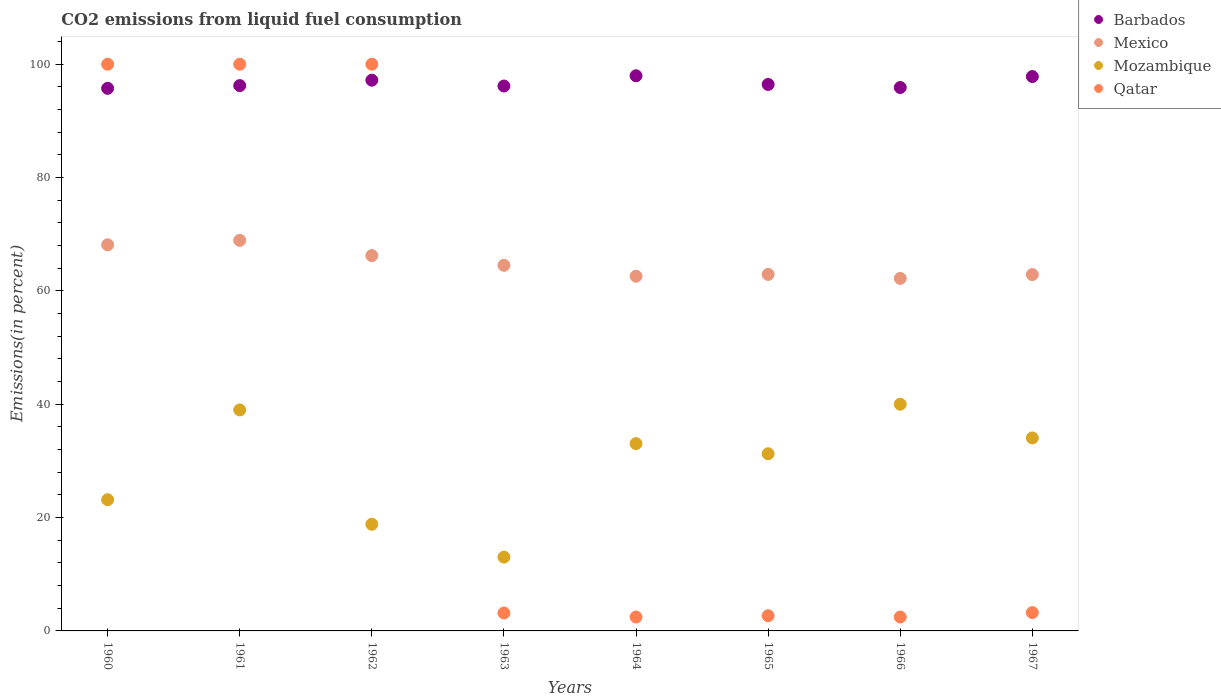Is the number of dotlines equal to the number of legend labels?
Give a very brief answer. Yes. What is the total CO2 emitted in Mexico in 1963?
Keep it short and to the point. 64.51. Across all years, what is the maximum total CO2 emitted in Mozambique?
Offer a terse response. 40. Across all years, what is the minimum total CO2 emitted in Mexico?
Make the answer very short. 62.21. What is the total total CO2 emitted in Qatar in the graph?
Keep it short and to the point. 313.99. What is the difference between the total CO2 emitted in Mozambique in 1965 and that in 1966?
Provide a succinct answer. -8.74. What is the difference between the total CO2 emitted in Mexico in 1961 and the total CO2 emitted in Barbados in 1963?
Provide a short and direct response. -27.23. What is the average total CO2 emitted in Mexico per year?
Give a very brief answer. 64.8. In the year 1962, what is the difference between the total CO2 emitted in Mexico and total CO2 emitted in Barbados?
Give a very brief answer. -30.95. In how many years, is the total CO2 emitted in Mexico greater than 84 %?
Offer a terse response. 0. What is the ratio of the total CO2 emitted in Mexico in 1961 to that in 1964?
Give a very brief answer. 1.1. Is the total CO2 emitted in Mexico in 1964 less than that in 1966?
Offer a terse response. No. What is the difference between the highest and the lowest total CO2 emitted in Mozambique?
Offer a terse response. 26.98. In how many years, is the total CO2 emitted in Mozambique greater than the average total CO2 emitted in Mozambique taken over all years?
Your answer should be compact. 5. Is the sum of the total CO2 emitted in Qatar in 1964 and 1967 greater than the maximum total CO2 emitted in Mozambique across all years?
Your response must be concise. No. Is it the case that in every year, the sum of the total CO2 emitted in Mexico and total CO2 emitted in Qatar  is greater than the sum of total CO2 emitted in Mozambique and total CO2 emitted in Barbados?
Keep it short and to the point. No. Does the total CO2 emitted in Qatar monotonically increase over the years?
Make the answer very short. No. Is the total CO2 emitted in Qatar strictly greater than the total CO2 emitted in Mexico over the years?
Offer a terse response. No. Is the total CO2 emitted in Mexico strictly less than the total CO2 emitted in Mozambique over the years?
Offer a very short reply. No. How many years are there in the graph?
Make the answer very short. 8. What is the difference between two consecutive major ticks on the Y-axis?
Give a very brief answer. 20. Does the graph contain any zero values?
Offer a terse response. No. Where does the legend appear in the graph?
Offer a terse response. Top right. What is the title of the graph?
Ensure brevity in your answer.  CO2 emissions from liquid fuel consumption. Does "Middle income" appear as one of the legend labels in the graph?
Provide a short and direct response. No. What is the label or title of the X-axis?
Make the answer very short. Years. What is the label or title of the Y-axis?
Ensure brevity in your answer.  Emissions(in percent). What is the Emissions(in percent) in Barbados in 1960?
Give a very brief answer. 95.74. What is the Emissions(in percent) in Mexico in 1960?
Provide a short and direct response. 68.13. What is the Emissions(in percent) in Mozambique in 1960?
Keep it short and to the point. 23.15. What is the Emissions(in percent) in Qatar in 1960?
Offer a very short reply. 100. What is the Emissions(in percent) in Barbados in 1961?
Offer a terse response. 96.23. What is the Emissions(in percent) of Mexico in 1961?
Provide a short and direct response. 68.92. What is the Emissions(in percent) of Mozambique in 1961?
Offer a terse response. 39. What is the Emissions(in percent) of Qatar in 1961?
Your answer should be compact. 100. What is the Emissions(in percent) of Barbados in 1962?
Your response must be concise. 97.18. What is the Emissions(in percent) in Mexico in 1962?
Your answer should be very brief. 66.23. What is the Emissions(in percent) in Mozambique in 1962?
Offer a very short reply. 18.82. What is the Emissions(in percent) in Qatar in 1962?
Give a very brief answer. 100. What is the Emissions(in percent) in Barbados in 1963?
Give a very brief answer. 96.15. What is the Emissions(in percent) in Mexico in 1963?
Provide a short and direct response. 64.51. What is the Emissions(in percent) of Mozambique in 1963?
Ensure brevity in your answer.  13.02. What is the Emissions(in percent) in Qatar in 1963?
Your answer should be very brief. 3.17. What is the Emissions(in percent) of Barbados in 1964?
Your response must be concise. 97.96. What is the Emissions(in percent) in Mexico in 1964?
Your answer should be compact. 62.59. What is the Emissions(in percent) of Mozambique in 1964?
Offer a terse response. 33.05. What is the Emissions(in percent) in Qatar in 1964?
Ensure brevity in your answer.  2.45. What is the Emissions(in percent) in Barbados in 1965?
Offer a very short reply. 96.43. What is the Emissions(in percent) in Mexico in 1965?
Your response must be concise. 62.91. What is the Emissions(in percent) of Mozambique in 1965?
Make the answer very short. 31.26. What is the Emissions(in percent) of Qatar in 1965?
Your answer should be very brief. 2.68. What is the Emissions(in percent) of Barbados in 1966?
Keep it short and to the point. 95.89. What is the Emissions(in percent) of Mexico in 1966?
Make the answer very short. 62.21. What is the Emissions(in percent) in Qatar in 1966?
Provide a short and direct response. 2.45. What is the Emissions(in percent) of Barbados in 1967?
Offer a very short reply. 97.83. What is the Emissions(in percent) of Mexico in 1967?
Your answer should be compact. 62.88. What is the Emissions(in percent) in Mozambique in 1967?
Give a very brief answer. 34.05. What is the Emissions(in percent) of Qatar in 1967?
Keep it short and to the point. 3.23. Across all years, what is the maximum Emissions(in percent) in Barbados?
Keep it short and to the point. 97.96. Across all years, what is the maximum Emissions(in percent) in Mexico?
Offer a terse response. 68.92. Across all years, what is the maximum Emissions(in percent) in Mozambique?
Provide a succinct answer. 40. Across all years, what is the minimum Emissions(in percent) of Barbados?
Provide a short and direct response. 95.74. Across all years, what is the minimum Emissions(in percent) of Mexico?
Give a very brief answer. 62.21. Across all years, what is the minimum Emissions(in percent) of Mozambique?
Provide a succinct answer. 13.02. Across all years, what is the minimum Emissions(in percent) in Qatar?
Your response must be concise. 2.45. What is the total Emissions(in percent) in Barbados in the graph?
Your answer should be compact. 773.41. What is the total Emissions(in percent) of Mexico in the graph?
Make the answer very short. 518.38. What is the total Emissions(in percent) in Mozambique in the graph?
Your answer should be compact. 232.35. What is the total Emissions(in percent) of Qatar in the graph?
Ensure brevity in your answer.  313.99. What is the difference between the Emissions(in percent) of Barbados in 1960 and that in 1961?
Offer a very short reply. -0.48. What is the difference between the Emissions(in percent) in Mexico in 1960 and that in 1961?
Your response must be concise. -0.79. What is the difference between the Emissions(in percent) in Mozambique in 1960 and that in 1961?
Ensure brevity in your answer.  -15.85. What is the difference between the Emissions(in percent) in Barbados in 1960 and that in 1962?
Keep it short and to the point. -1.44. What is the difference between the Emissions(in percent) in Mexico in 1960 and that in 1962?
Provide a short and direct response. 1.9. What is the difference between the Emissions(in percent) in Mozambique in 1960 and that in 1962?
Provide a short and direct response. 4.33. What is the difference between the Emissions(in percent) of Barbados in 1960 and that in 1963?
Keep it short and to the point. -0.41. What is the difference between the Emissions(in percent) in Mexico in 1960 and that in 1963?
Keep it short and to the point. 3.62. What is the difference between the Emissions(in percent) of Mozambique in 1960 and that in 1963?
Your response must be concise. 10.13. What is the difference between the Emissions(in percent) of Qatar in 1960 and that in 1963?
Ensure brevity in your answer.  96.83. What is the difference between the Emissions(in percent) in Barbados in 1960 and that in 1964?
Make the answer very short. -2.21. What is the difference between the Emissions(in percent) in Mexico in 1960 and that in 1964?
Your answer should be very brief. 5.54. What is the difference between the Emissions(in percent) in Mozambique in 1960 and that in 1964?
Provide a succinct answer. -9.9. What is the difference between the Emissions(in percent) in Qatar in 1960 and that in 1964?
Offer a very short reply. 97.55. What is the difference between the Emissions(in percent) in Barbados in 1960 and that in 1965?
Provide a short and direct response. -0.68. What is the difference between the Emissions(in percent) in Mexico in 1960 and that in 1965?
Your response must be concise. 5.22. What is the difference between the Emissions(in percent) in Mozambique in 1960 and that in 1965?
Keep it short and to the point. -8.11. What is the difference between the Emissions(in percent) in Qatar in 1960 and that in 1965?
Provide a short and direct response. 97.32. What is the difference between the Emissions(in percent) of Barbados in 1960 and that in 1966?
Provide a short and direct response. -0.15. What is the difference between the Emissions(in percent) of Mexico in 1960 and that in 1966?
Keep it short and to the point. 5.93. What is the difference between the Emissions(in percent) of Mozambique in 1960 and that in 1966?
Offer a very short reply. -16.85. What is the difference between the Emissions(in percent) of Qatar in 1960 and that in 1966?
Make the answer very short. 97.55. What is the difference between the Emissions(in percent) in Barbados in 1960 and that in 1967?
Your response must be concise. -2.08. What is the difference between the Emissions(in percent) of Mexico in 1960 and that in 1967?
Provide a short and direct response. 5.25. What is the difference between the Emissions(in percent) of Mozambique in 1960 and that in 1967?
Make the answer very short. -10.9. What is the difference between the Emissions(in percent) in Qatar in 1960 and that in 1967?
Your answer should be very brief. 96.77. What is the difference between the Emissions(in percent) in Barbados in 1961 and that in 1962?
Your answer should be very brief. -0.96. What is the difference between the Emissions(in percent) in Mexico in 1961 and that in 1962?
Make the answer very short. 2.69. What is the difference between the Emissions(in percent) in Mozambique in 1961 and that in 1962?
Your answer should be compact. 20.18. What is the difference between the Emissions(in percent) of Qatar in 1961 and that in 1962?
Provide a succinct answer. 0. What is the difference between the Emissions(in percent) of Barbados in 1961 and that in 1963?
Offer a very short reply. 0.07. What is the difference between the Emissions(in percent) in Mexico in 1961 and that in 1963?
Keep it short and to the point. 4.41. What is the difference between the Emissions(in percent) in Mozambique in 1961 and that in 1963?
Your answer should be compact. 25.97. What is the difference between the Emissions(in percent) of Qatar in 1961 and that in 1963?
Provide a short and direct response. 96.83. What is the difference between the Emissions(in percent) of Barbados in 1961 and that in 1964?
Provide a short and direct response. -1.73. What is the difference between the Emissions(in percent) of Mexico in 1961 and that in 1964?
Keep it short and to the point. 6.33. What is the difference between the Emissions(in percent) of Mozambique in 1961 and that in 1964?
Offer a very short reply. 5.95. What is the difference between the Emissions(in percent) in Qatar in 1961 and that in 1964?
Offer a very short reply. 97.55. What is the difference between the Emissions(in percent) of Barbados in 1961 and that in 1965?
Your answer should be compact. -0.2. What is the difference between the Emissions(in percent) of Mexico in 1961 and that in 1965?
Make the answer very short. 6.01. What is the difference between the Emissions(in percent) in Mozambique in 1961 and that in 1965?
Your response must be concise. 7.74. What is the difference between the Emissions(in percent) of Qatar in 1961 and that in 1965?
Keep it short and to the point. 97.32. What is the difference between the Emissions(in percent) of Barbados in 1961 and that in 1966?
Your answer should be very brief. 0.34. What is the difference between the Emissions(in percent) in Mexico in 1961 and that in 1966?
Provide a succinct answer. 6.71. What is the difference between the Emissions(in percent) in Mozambique in 1961 and that in 1966?
Offer a very short reply. -1. What is the difference between the Emissions(in percent) in Qatar in 1961 and that in 1966?
Give a very brief answer. 97.55. What is the difference between the Emissions(in percent) in Barbados in 1961 and that in 1967?
Your response must be concise. -1.6. What is the difference between the Emissions(in percent) of Mexico in 1961 and that in 1967?
Offer a terse response. 6.04. What is the difference between the Emissions(in percent) of Mozambique in 1961 and that in 1967?
Provide a short and direct response. 4.95. What is the difference between the Emissions(in percent) of Qatar in 1961 and that in 1967?
Make the answer very short. 96.77. What is the difference between the Emissions(in percent) of Barbados in 1962 and that in 1963?
Keep it short and to the point. 1.03. What is the difference between the Emissions(in percent) of Mexico in 1962 and that in 1963?
Your response must be concise. 1.72. What is the difference between the Emissions(in percent) of Mozambique in 1962 and that in 1963?
Offer a terse response. 5.79. What is the difference between the Emissions(in percent) in Qatar in 1962 and that in 1963?
Provide a short and direct response. 96.83. What is the difference between the Emissions(in percent) of Barbados in 1962 and that in 1964?
Your answer should be very brief. -0.78. What is the difference between the Emissions(in percent) in Mexico in 1962 and that in 1964?
Keep it short and to the point. 3.64. What is the difference between the Emissions(in percent) of Mozambique in 1962 and that in 1964?
Offer a terse response. -14.23. What is the difference between the Emissions(in percent) in Qatar in 1962 and that in 1964?
Provide a succinct answer. 97.55. What is the difference between the Emissions(in percent) in Barbados in 1962 and that in 1965?
Offer a very short reply. 0.75. What is the difference between the Emissions(in percent) of Mexico in 1962 and that in 1965?
Provide a succinct answer. 3.32. What is the difference between the Emissions(in percent) in Mozambique in 1962 and that in 1965?
Your answer should be very brief. -12.44. What is the difference between the Emissions(in percent) in Qatar in 1962 and that in 1965?
Offer a terse response. 97.32. What is the difference between the Emissions(in percent) in Barbados in 1962 and that in 1966?
Give a very brief answer. 1.29. What is the difference between the Emissions(in percent) in Mexico in 1962 and that in 1966?
Provide a succinct answer. 4.03. What is the difference between the Emissions(in percent) in Mozambique in 1962 and that in 1966?
Offer a terse response. -21.18. What is the difference between the Emissions(in percent) in Qatar in 1962 and that in 1966?
Ensure brevity in your answer.  97.55. What is the difference between the Emissions(in percent) of Barbados in 1962 and that in 1967?
Provide a succinct answer. -0.64. What is the difference between the Emissions(in percent) in Mexico in 1962 and that in 1967?
Offer a terse response. 3.35. What is the difference between the Emissions(in percent) in Mozambique in 1962 and that in 1967?
Your answer should be compact. -15.23. What is the difference between the Emissions(in percent) of Qatar in 1962 and that in 1967?
Keep it short and to the point. 96.77. What is the difference between the Emissions(in percent) of Barbados in 1963 and that in 1964?
Your response must be concise. -1.81. What is the difference between the Emissions(in percent) of Mexico in 1963 and that in 1964?
Make the answer very short. 1.92. What is the difference between the Emissions(in percent) of Mozambique in 1963 and that in 1964?
Make the answer very short. -20.02. What is the difference between the Emissions(in percent) in Qatar in 1963 and that in 1964?
Ensure brevity in your answer.  0.71. What is the difference between the Emissions(in percent) in Barbados in 1963 and that in 1965?
Your answer should be very brief. -0.27. What is the difference between the Emissions(in percent) of Mexico in 1963 and that in 1965?
Keep it short and to the point. 1.6. What is the difference between the Emissions(in percent) of Mozambique in 1963 and that in 1965?
Make the answer very short. -18.24. What is the difference between the Emissions(in percent) of Qatar in 1963 and that in 1965?
Provide a short and direct response. 0.49. What is the difference between the Emissions(in percent) of Barbados in 1963 and that in 1966?
Provide a short and direct response. 0.26. What is the difference between the Emissions(in percent) of Mexico in 1963 and that in 1966?
Offer a very short reply. 2.31. What is the difference between the Emissions(in percent) of Mozambique in 1963 and that in 1966?
Your response must be concise. -26.98. What is the difference between the Emissions(in percent) of Qatar in 1963 and that in 1966?
Keep it short and to the point. 0.71. What is the difference between the Emissions(in percent) of Barbados in 1963 and that in 1967?
Ensure brevity in your answer.  -1.67. What is the difference between the Emissions(in percent) in Mexico in 1963 and that in 1967?
Offer a very short reply. 1.63. What is the difference between the Emissions(in percent) of Mozambique in 1963 and that in 1967?
Provide a succinct answer. -21.03. What is the difference between the Emissions(in percent) of Qatar in 1963 and that in 1967?
Offer a terse response. -0.07. What is the difference between the Emissions(in percent) in Barbados in 1964 and that in 1965?
Give a very brief answer. 1.53. What is the difference between the Emissions(in percent) of Mexico in 1964 and that in 1965?
Your answer should be very brief. -0.32. What is the difference between the Emissions(in percent) in Mozambique in 1964 and that in 1965?
Offer a very short reply. 1.79. What is the difference between the Emissions(in percent) of Qatar in 1964 and that in 1965?
Your response must be concise. -0.23. What is the difference between the Emissions(in percent) of Barbados in 1964 and that in 1966?
Your response must be concise. 2.07. What is the difference between the Emissions(in percent) of Mexico in 1964 and that in 1966?
Give a very brief answer. 0.38. What is the difference between the Emissions(in percent) of Mozambique in 1964 and that in 1966?
Offer a terse response. -6.95. What is the difference between the Emissions(in percent) in Qatar in 1964 and that in 1966?
Provide a short and direct response. 0. What is the difference between the Emissions(in percent) in Barbados in 1964 and that in 1967?
Your answer should be compact. 0.13. What is the difference between the Emissions(in percent) in Mexico in 1964 and that in 1967?
Offer a terse response. -0.29. What is the difference between the Emissions(in percent) in Mozambique in 1964 and that in 1967?
Provide a short and direct response. -1. What is the difference between the Emissions(in percent) in Qatar in 1964 and that in 1967?
Your answer should be very brief. -0.78. What is the difference between the Emissions(in percent) in Barbados in 1965 and that in 1966?
Offer a terse response. 0.54. What is the difference between the Emissions(in percent) of Mexico in 1965 and that in 1966?
Ensure brevity in your answer.  0.7. What is the difference between the Emissions(in percent) in Mozambique in 1965 and that in 1966?
Give a very brief answer. -8.74. What is the difference between the Emissions(in percent) in Qatar in 1965 and that in 1966?
Keep it short and to the point. 0.23. What is the difference between the Emissions(in percent) of Barbados in 1965 and that in 1967?
Your answer should be compact. -1.4. What is the difference between the Emissions(in percent) of Mexico in 1965 and that in 1967?
Ensure brevity in your answer.  0.03. What is the difference between the Emissions(in percent) of Mozambique in 1965 and that in 1967?
Provide a succinct answer. -2.79. What is the difference between the Emissions(in percent) of Qatar in 1965 and that in 1967?
Ensure brevity in your answer.  -0.55. What is the difference between the Emissions(in percent) in Barbados in 1966 and that in 1967?
Offer a very short reply. -1.94. What is the difference between the Emissions(in percent) in Mexico in 1966 and that in 1967?
Keep it short and to the point. -0.67. What is the difference between the Emissions(in percent) of Mozambique in 1966 and that in 1967?
Offer a terse response. 5.95. What is the difference between the Emissions(in percent) of Qatar in 1966 and that in 1967?
Provide a succinct answer. -0.78. What is the difference between the Emissions(in percent) in Barbados in 1960 and the Emissions(in percent) in Mexico in 1961?
Your answer should be very brief. 26.82. What is the difference between the Emissions(in percent) in Barbados in 1960 and the Emissions(in percent) in Mozambique in 1961?
Provide a succinct answer. 56.75. What is the difference between the Emissions(in percent) in Barbados in 1960 and the Emissions(in percent) in Qatar in 1961?
Provide a succinct answer. -4.26. What is the difference between the Emissions(in percent) of Mexico in 1960 and the Emissions(in percent) of Mozambique in 1961?
Your answer should be very brief. 29.14. What is the difference between the Emissions(in percent) in Mexico in 1960 and the Emissions(in percent) in Qatar in 1961?
Give a very brief answer. -31.87. What is the difference between the Emissions(in percent) of Mozambique in 1960 and the Emissions(in percent) of Qatar in 1961?
Ensure brevity in your answer.  -76.85. What is the difference between the Emissions(in percent) of Barbados in 1960 and the Emissions(in percent) of Mexico in 1962?
Offer a terse response. 29.51. What is the difference between the Emissions(in percent) of Barbados in 1960 and the Emissions(in percent) of Mozambique in 1962?
Provide a succinct answer. 76.93. What is the difference between the Emissions(in percent) in Barbados in 1960 and the Emissions(in percent) in Qatar in 1962?
Offer a terse response. -4.26. What is the difference between the Emissions(in percent) of Mexico in 1960 and the Emissions(in percent) of Mozambique in 1962?
Give a very brief answer. 49.31. What is the difference between the Emissions(in percent) in Mexico in 1960 and the Emissions(in percent) in Qatar in 1962?
Offer a very short reply. -31.87. What is the difference between the Emissions(in percent) in Mozambique in 1960 and the Emissions(in percent) in Qatar in 1962?
Keep it short and to the point. -76.85. What is the difference between the Emissions(in percent) in Barbados in 1960 and the Emissions(in percent) in Mexico in 1963?
Ensure brevity in your answer.  31.23. What is the difference between the Emissions(in percent) in Barbados in 1960 and the Emissions(in percent) in Mozambique in 1963?
Provide a short and direct response. 82.72. What is the difference between the Emissions(in percent) in Barbados in 1960 and the Emissions(in percent) in Qatar in 1963?
Your answer should be compact. 92.58. What is the difference between the Emissions(in percent) in Mexico in 1960 and the Emissions(in percent) in Mozambique in 1963?
Provide a succinct answer. 55.11. What is the difference between the Emissions(in percent) of Mexico in 1960 and the Emissions(in percent) of Qatar in 1963?
Provide a short and direct response. 64.97. What is the difference between the Emissions(in percent) in Mozambique in 1960 and the Emissions(in percent) in Qatar in 1963?
Your response must be concise. 19.99. What is the difference between the Emissions(in percent) in Barbados in 1960 and the Emissions(in percent) in Mexico in 1964?
Keep it short and to the point. 33.16. What is the difference between the Emissions(in percent) of Barbados in 1960 and the Emissions(in percent) of Mozambique in 1964?
Your response must be concise. 62.7. What is the difference between the Emissions(in percent) of Barbados in 1960 and the Emissions(in percent) of Qatar in 1964?
Your answer should be very brief. 93.29. What is the difference between the Emissions(in percent) of Mexico in 1960 and the Emissions(in percent) of Mozambique in 1964?
Make the answer very short. 35.08. What is the difference between the Emissions(in percent) in Mexico in 1960 and the Emissions(in percent) in Qatar in 1964?
Offer a terse response. 65.68. What is the difference between the Emissions(in percent) in Mozambique in 1960 and the Emissions(in percent) in Qatar in 1964?
Offer a terse response. 20.7. What is the difference between the Emissions(in percent) of Barbados in 1960 and the Emissions(in percent) of Mexico in 1965?
Ensure brevity in your answer.  32.84. What is the difference between the Emissions(in percent) of Barbados in 1960 and the Emissions(in percent) of Mozambique in 1965?
Your answer should be compact. 64.48. What is the difference between the Emissions(in percent) in Barbados in 1960 and the Emissions(in percent) in Qatar in 1965?
Provide a succinct answer. 93.06. What is the difference between the Emissions(in percent) of Mexico in 1960 and the Emissions(in percent) of Mozambique in 1965?
Your answer should be very brief. 36.87. What is the difference between the Emissions(in percent) in Mexico in 1960 and the Emissions(in percent) in Qatar in 1965?
Your answer should be compact. 65.45. What is the difference between the Emissions(in percent) in Mozambique in 1960 and the Emissions(in percent) in Qatar in 1965?
Keep it short and to the point. 20.47. What is the difference between the Emissions(in percent) in Barbados in 1960 and the Emissions(in percent) in Mexico in 1966?
Provide a short and direct response. 33.54. What is the difference between the Emissions(in percent) in Barbados in 1960 and the Emissions(in percent) in Mozambique in 1966?
Keep it short and to the point. 55.74. What is the difference between the Emissions(in percent) of Barbados in 1960 and the Emissions(in percent) of Qatar in 1966?
Your answer should be compact. 93.29. What is the difference between the Emissions(in percent) in Mexico in 1960 and the Emissions(in percent) in Mozambique in 1966?
Ensure brevity in your answer.  28.13. What is the difference between the Emissions(in percent) in Mexico in 1960 and the Emissions(in percent) in Qatar in 1966?
Offer a very short reply. 65.68. What is the difference between the Emissions(in percent) in Mozambique in 1960 and the Emissions(in percent) in Qatar in 1966?
Keep it short and to the point. 20.7. What is the difference between the Emissions(in percent) in Barbados in 1960 and the Emissions(in percent) in Mexico in 1967?
Make the answer very short. 32.87. What is the difference between the Emissions(in percent) of Barbados in 1960 and the Emissions(in percent) of Mozambique in 1967?
Keep it short and to the point. 61.69. What is the difference between the Emissions(in percent) in Barbados in 1960 and the Emissions(in percent) in Qatar in 1967?
Your answer should be very brief. 92.51. What is the difference between the Emissions(in percent) in Mexico in 1960 and the Emissions(in percent) in Mozambique in 1967?
Make the answer very short. 34.08. What is the difference between the Emissions(in percent) in Mexico in 1960 and the Emissions(in percent) in Qatar in 1967?
Make the answer very short. 64.9. What is the difference between the Emissions(in percent) of Mozambique in 1960 and the Emissions(in percent) of Qatar in 1967?
Provide a succinct answer. 19.92. What is the difference between the Emissions(in percent) in Barbados in 1961 and the Emissions(in percent) in Mexico in 1962?
Provide a short and direct response. 29.99. What is the difference between the Emissions(in percent) of Barbados in 1961 and the Emissions(in percent) of Mozambique in 1962?
Ensure brevity in your answer.  77.41. What is the difference between the Emissions(in percent) in Barbados in 1961 and the Emissions(in percent) in Qatar in 1962?
Keep it short and to the point. -3.77. What is the difference between the Emissions(in percent) in Mexico in 1961 and the Emissions(in percent) in Mozambique in 1962?
Your response must be concise. 50.1. What is the difference between the Emissions(in percent) in Mexico in 1961 and the Emissions(in percent) in Qatar in 1962?
Your response must be concise. -31.08. What is the difference between the Emissions(in percent) in Mozambique in 1961 and the Emissions(in percent) in Qatar in 1962?
Keep it short and to the point. -61. What is the difference between the Emissions(in percent) in Barbados in 1961 and the Emissions(in percent) in Mexico in 1963?
Keep it short and to the point. 31.71. What is the difference between the Emissions(in percent) of Barbados in 1961 and the Emissions(in percent) of Mozambique in 1963?
Offer a very short reply. 83.2. What is the difference between the Emissions(in percent) in Barbados in 1961 and the Emissions(in percent) in Qatar in 1963?
Keep it short and to the point. 93.06. What is the difference between the Emissions(in percent) of Mexico in 1961 and the Emissions(in percent) of Mozambique in 1963?
Ensure brevity in your answer.  55.9. What is the difference between the Emissions(in percent) in Mexico in 1961 and the Emissions(in percent) in Qatar in 1963?
Provide a succinct answer. 65.75. What is the difference between the Emissions(in percent) of Mozambique in 1961 and the Emissions(in percent) of Qatar in 1963?
Ensure brevity in your answer.  35.83. What is the difference between the Emissions(in percent) in Barbados in 1961 and the Emissions(in percent) in Mexico in 1964?
Your answer should be compact. 33.64. What is the difference between the Emissions(in percent) in Barbados in 1961 and the Emissions(in percent) in Mozambique in 1964?
Your response must be concise. 63.18. What is the difference between the Emissions(in percent) of Barbados in 1961 and the Emissions(in percent) of Qatar in 1964?
Offer a terse response. 93.77. What is the difference between the Emissions(in percent) in Mexico in 1961 and the Emissions(in percent) in Mozambique in 1964?
Make the answer very short. 35.87. What is the difference between the Emissions(in percent) in Mexico in 1961 and the Emissions(in percent) in Qatar in 1964?
Make the answer very short. 66.47. What is the difference between the Emissions(in percent) of Mozambique in 1961 and the Emissions(in percent) of Qatar in 1964?
Give a very brief answer. 36.54. What is the difference between the Emissions(in percent) in Barbados in 1961 and the Emissions(in percent) in Mexico in 1965?
Give a very brief answer. 33.32. What is the difference between the Emissions(in percent) in Barbados in 1961 and the Emissions(in percent) in Mozambique in 1965?
Make the answer very short. 64.97. What is the difference between the Emissions(in percent) of Barbados in 1961 and the Emissions(in percent) of Qatar in 1965?
Provide a short and direct response. 93.55. What is the difference between the Emissions(in percent) of Mexico in 1961 and the Emissions(in percent) of Mozambique in 1965?
Offer a terse response. 37.66. What is the difference between the Emissions(in percent) in Mexico in 1961 and the Emissions(in percent) in Qatar in 1965?
Your answer should be compact. 66.24. What is the difference between the Emissions(in percent) in Mozambique in 1961 and the Emissions(in percent) in Qatar in 1965?
Offer a terse response. 36.32. What is the difference between the Emissions(in percent) of Barbados in 1961 and the Emissions(in percent) of Mexico in 1966?
Provide a short and direct response. 34.02. What is the difference between the Emissions(in percent) in Barbados in 1961 and the Emissions(in percent) in Mozambique in 1966?
Your answer should be very brief. 56.23. What is the difference between the Emissions(in percent) in Barbados in 1961 and the Emissions(in percent) in Qatar in 1966?
Provide a short and direct response. 93.77. What is the difference between the Emissions(in percent) of Mexico in 1961 and the Emissions(in percent) of Mozambique in 1966?
Keep it short and to the point. 28.92. What is the difference between the Emissions(in percent) of Mexico in 1961 and the Emissions(in percent) of Qatar in 1966?
Ensure brevity in your answer.  66.47. What is the difference between the Emissions(in percent) of Mozambique in 1961 and the Emissions(in percent) of Qatar in 1966?
Offer a very short reply. 36.54. What is the difference between the Emissions(in percent) in Barbados in 1961 and the Emissions(in percent) in Mexico in 1967?
Keep it short and to the point. 33.35. What is the difference between the Emissions(in percent) in Barbados in 1961 and the Emissions(in percent) in Mozambique in 1967?
Offer a terse response. 62.18. What is the difference between the Emissions(in percent) in Barbados in 1961 and the Emissions(in percent) in Qatar in 1967?
Provide a succinct answer. 92.99. What is the difference between the Emissions(in percent) of Mexico in 1961 and the Emissions(in percent) of Mozambique in 1967?
Offer a terse response. 34.87. What is the difference between the Emissions(in percent) of Mexico in 1961 and the Emissions(in percent) of Qatar in 1967?
Give a very brief answer. 65.69. What is the difference between the Emissions(in percent) in Mozambique in 1961 and the Emissions(in percent) in Qatar in 1967?
Keep it short and to the point. 35.76. What is the difference between the Emissions(in percent) of Barbados in 1962 and the Emissions(in percent) of Mexico in 1963?
Offer a terse response. 32.67. What is the difference between the Emissions(in percent) in Barbados in 1962 and the Emissions(in percent) in Mozambique in 1963?
Keep it short and to the point. 84.16. What is the difference between the Emissions(in percent) in Barbados in 1962 and the Emissions(in percent) in Qatar in 1963?
Give a very brief answer. 94.02. What is the difference between the Emissions(in percent) in Mexico in 1962 and the Emissions(in percent) in Mozambique in 1963?
Keep it short and to the point. 53.21. What is the difference between the Emissions(in percent) of Mexico in 1962 and the Emissions(in percent) of Qatar in 1963?
Give a very brief answer. 63.07. What is the difference between the Emissions(in percent) of Mozambique in 1962 and the Emissions(in percent) of Qatar in 1963?
Give a very brief answer. 15.65. What is the difference between the Emissions(in percent) of Barbados in 1962 and the Emissions(in percent) of Mexico in 1964?
Keep it short and to the point. 34.59. What is the difference between the Emissions(in percent) in Barbados in 1962 and the Emissions(in percent) in Mozambique in 1964?
Provide a succinct answer. 64.14. What is the difference between the Emissions(in percent) of Barbados in 1962 and the Emissions(in percent) of Qatar in 1964?
Give a very brief answer. 94.73. What is the difference between the Emissions(in percent) in Mexico in 1962 and the Emissions(in percent) in Mozambique in 1964?
Ensure brevity in your answer.  33.18. What is the difference between the Emissions(in percent) of Mexico in 1962 and the Emissions(in percent) of Qatar in 1964?
Provide a short and direct response. 63.78. What is the difference between the Emissions(in percent) in Mozambique in 1962 and the Emissions(in percent) in Qatar in 1964?
Provide a short and direct response. 16.36. What is the difference between the Emissions(in percent) in Barbados in 1962 and the Emissions(in percent) in Mexico in 1965?
Your answer should be compact. 34.27. What is the difference between the Emissions(in percent) of Barbados in 1962 and the Emissions(in percent) of Mozambique in 1965?
Offer a terse response. 65.92. What is the difference between the Emissions(in percent) in Barbados in 1962 and the Emissions(in percent) in Qatar in 1965?
Offer a very short reply. 94.5. What is the difference between the Emissions(in percent) of Mexico in 1962 and the Emissions(in percent) of Mozambique in 1965?
Offer a very short reply. 34.97. What is the difference between the Emissions(in percent) in Mexico in 1962 and the Emissions(in percent) in Qatar in 1965?
Offer a terse response. 63.55. What is the difference between the Emissions(in percent) of Mozambique in 1962 and the Emissions(in percent) of Qatar in 1965?
Make the answer very short. 16.14. What is the difference between the Emissions(in percent) in Barbados in 1962 and the Emissions(in percent) in Mexico in 1966?
Your answer should be compact. 34.98. What is the difference between the Emissions(in percent) in Barbados in 1962 and the Emissions(in percent) in Mozambique in 1966?
Ensure brevity in your answer.  57.18. What is the difference between the Emissions(in percent) of Barbados in 1962 and the Emissions(in percent) of Qatar in 1966?
Provide a short and direct response. 94.73. What is the difference between the Emissions(in percent) of Mexico in 1962 and the Emissions(in percent) of Mozambique in 1966?
Offer a very short reply. 26.23. What is the difference between the Emissions(in percent) in Mexico in 1962 and the Emissions(in percent) in Qatar in 1966?
Provide a short and direct response. 63.78. What is the difference between the Emissions(in percent) of Mozambique in 1962 and the Emissions(in percent) of Qatar in 1966?
Provide a short and direct response. 16.37. What is the difference between the Emissions(in percent) in Barbados in 1962 and the Emissions(in percent) in Mexico in 1967?
Offer a terse response. 34.3. What is the difference between the Emissions(in percent) of Barbados in 1962 and the Emissions(in percent) of Mozambique in 1967?
Provide a succinct answer. 63.13. What is the difference between the Emissions(in percent) of Barbados in 1962 and the Emissions(in percent) of Qatar in 1967?
Your answer should be very brief. 93.95. What is the difference between the Emissions(in percent) of Mexico in 1962 and the Emissions(in percent) of Mozambique in 1967?
Offer a very short reply. 32.18. What is the difference between the Emissions(in percent) of Mexico in 1962 and the Emissions(in percent) of Qatar in 1967?
Make the answer very short. 63. What is the difference between the Emissions(in percent) in Mozambique in 1962 and the Emissions(in percent) in Qatar in 1967?
Ensure brevity in your answer.  15.58. What is the difference between the Emissions(in percent) of Barbados in 1963 and the Emissions(in percent) of Mexico in 1964?
Ensure brevity in your answer.  33.56. What is the difference between the Emissions(in percent) in Barbados in 1963 and the Emissions(in percent) in Mozambique in 1964?
Keep it short and to the point. 63.11. What is the difference between the Emissions(in percent) of Barbados in 1963 and the Emissions(in percent) of Qatar in 1964?
Offer a very short reply. 93.7. What is the difference between the Emissions(in percent) of Mexico in 1963 and the Emissions(in percent) of Mozambique in 1964?
Make the answer very short. 31.47. What is the difference between the Emissions(in percent) of Mexico in 1963 and the Emissions(in percent) of Qatar in 1964?
Offer a terse response. 62.06. What is the difference between the Emissions(in percent) in Mozambique in 1963 and the Emissions(in percent) in Qatar in 1964?
Ensure brevity in your answer.  10.57. What is the difference between the Emissions(in percent) of Barbados in 1963 and the Emissions(in percent) of Mexico in 1965?
Your answer should be very brief. 33.24. What is the difference between the Emissions(in percent) in Barbados in 1963 and the Emissions(in percent) in Mozambique in 1965?
Your response must be concise. 64.89. What is the difference between the Emissions(in percent) in Barbados in 1963 and the Emissions(in percent) in Qatar in 1965?
Your answer should be compact. 93.47. What is the difference between the Emissions(in percent) of Mexico in 1963 and the Emissions(in percent) of Mozambique in 1965?
Keep it short and to the point. 33.25. What is the difference between the Emissions(in percent) in Mexico in 1963 and the Emissions(in percent) in Qatar in 1965?
Provide a succinct answer. 61.83. What is the difference between the Emissions(in percent) in Mozambique in 1963 and the Emissions(in percent) in Qatar in 1965?
Ensure brevity in your answer.  10.34. What is the difference between the Emissions(in percent) in Barbados in 1963 and the Emissions(in percent) in Mexico in 1966?
Your response must be concise. 33.95. What is the difference between the Emissions(in percent) in Barbados in 1963 and the Emissions(in percent) in Mozambique in 1966?
Provide a succinct answer. 56.15. What is the difference between the Emissions(in percent) of Barbados in 1963 and the Emissions(in percent) of Qatar in 1966?
Provide a short and direct response. 93.7. What is the difference between the Emissions(in percent) of Mexico in 1963 and the Emissions(in percent) of Mozambique in 1966?
Make the answer very short. 24.51. What is the difference between the Emissions(in percent) of Mexico in 1963 and the Emissions(in percent) of Qatar in 1966?
Offer a terse response. 62.06. What is the difference between the Emissions(in percent) in Mozambique in 1963 and the Emissions(in percent) in Qatar in 1966?
Ensure brevity in your answer.  10.57. What is the difference between the Emissions(in percent) of Barbados in 1963 and the Emissions(in percent) of Mexico in 1967?
Make the answer very short. 33.27. What is the difference between the Emissions(in percent) of Barbados in 1963 and the Emissions(in percent) of Mozambique in 1967?
Keep it short and to the point. 62.1. What is the difference between the Emissions(in percent) in Barbados in 1963 and the Emissions(in percent) in Qatar in 1967?
Provide a short and direct response. 92.92. What is the difference between the Emissions(in percent) in Mexico in 1963 and the Emissions(in percent) in Mozambique in 1967?
Keep it short and to the point. 30.46. What is the difference between the Emissions(in percent) of Mexico in 1963 and the Emissions(in percent) of Qatar in 1967?
Your answer should be compact. 61.28. What is the difference between the Emissions(in percent) of Mozambique in 1963 and the Emissions(in percent) of Qatar in 1967?
Offer a terse response. 9.79. What is the difference between the Emissions(in percent) in Barbados in 1964 and the Emissions(in percent) in Mexico in 1965?
Make the answer very short. 35.05. What is the difference between the Emissions(in percent) of Barbados in 1964 and the Emissions(in percent) of Mozambique in 1965?
Your answer should be compact. 66.7. What is the difference between the Emissions(in percent) of Barbados in 1964 and the Emissions(in percent) of Qatar in 1965?
Provide a short and direct response. 95.28. What is the difference between the Emissions(in percent) of Mexico in 1964 and the Emissions(in percent) of Mozambique in 1965?
Give a very brief answer. 31.33. What is the difference between the Emissions(in percent) in Mexico in 1964 and the Emissions(in percent) in Qatar in 1965?
Provide a succinct answer. 59.91. What is the difference between the Emissions(in percent) in Mozambique in 1964 and the Emissions(in percent) in Qatar in 1965?
Offer a terse response. 30.37. What is the difference between the Emissions(in percent) in Barbados in 1964 and the Emissions(in percent) in Mexico in 1966?
Offer a very short reply. 35.75. What is the difference between the Emissions(in percent) of Barbados in 1964 and the Emissions(in percent) of Mozambique in 1966?
Offer a terse response. 57.96. What is the difference between the Emissions(in percent) in Barbados in 1964 and the Emissions(in percent) in Qatar in 1966?
Offer a terse response. 95.51. What is the difference between the Emissions(in percent) of Mexico in 1964 and the Emissions(in percent) of Mozambique in 1966?
Offer a terse response. 22.59. What is the difference between the Emissions(in percent) of Mexico in 1964 and the Emissions(in percent) of Qatar in 1966?
Your response must be concise. 60.14. What is the difference between the Emissions(in percent) of Mozambique in 1964 and the Emissions(in percent) of Qatar in 1966?
Give a very brief answer. 30.59. What is the difference between the Emissions(in percent) in Barbados in 1964 and the Emissions(in percent) in Mexico in 1967?
Offer a terse response. 35.08. What is the difference between the Emissions(in percent) of Barbados in 1964 and the Emissions(in percent) of Mozambique in 1967?
Offer a terse response. 63.91. What is the difference between the Emissions(in percent) of Barbados in 1964 and the Emissions(in percent) of Qatar in 1967?
Offer a terse response. 94.72. What is the difference between the Emissions(in percent) in Mexico in 1964 and the Emissions(in percent) in Mozambique in 1967?
Give a very brief answer. 28.54. What is the difference between the Emissions(in percent) in Mexico in 1964 and the Emissions(in percent) in Qatar in 1967?
Your answer should be very brief. 59.35. What is the difference between the Emissions(in percent) in Mozambique in 1964 and the Emissions(in percent) in Qatar in 1967?
Your answer should be compact. 29.81. What is the difference between the Emissions(in percent) of Barbados in 1965 and the Emissions(in percent) of Mexico in 1966?
Your response must be concise. 34.22. What is the difference between the Emissions(in percent) of Barbados in 1965 and the Emissions(in percent) of Mozambique in 1966?
Your response must be concise. 56.43. What is the difference between the Emissions(in percent) in Barbados in 1965 and the Emissions(in percent) in Qatar in 1966?
Your answer should be very brief. 93.98. What is the difference between the Emissions(in percent) of Mexico in 1965 and the Emissions(in percent) of Mozambique in 1966?
Give a very brief answer. 22.91. What is the difference between the Emissions(in percent) in Mexico in 1965 and the Emissions(in percent) in Qatar in 1966?
Offer a very short reply. 60.46. What is the difference between the Emissions(in percent) of Mozambique in 1965 and the Emissions(in percent) of Qatar in 1966?
Offer a very short reply. 28.81. What is the difference between the Emissions(in percent) of Barbados in 1965 and the Emissions(in percent) of Mexico in 1967?
Provide a succinct answer. 33.55. What is the difference between the Emissions(in percent) in Barbados in 1965 and the Emissions(in percent) in Mozambique in 1967?
Keep it short and to the point. 62.38. What is the difference between the Emissions(in percent) of Barbados in 1965 and the Emissions(in percent) of Qatar in 1967?
Make the answer very short. 93.19. What is the difference between the Emissions(in percent) of Mexico in 1965 and the Emissions(in percent) of Mozambique in 1967?
Provide a succinct answer. 28.86. What is the difference between the Emissions(in percent) of Mexico in 1965 and the Emissions(in percent) of Qatar in 1967?
Provide a short and direct response. 59.67. What is the difference between the Emissions(in percent) in Mozambique in 1965 and the Emissions(in percent) in Qatar in 1967?
Keep it short and to the point. 28.03. What is the difference between the Emissions(in percent) in Barbados in 1966 and the Emissions(in percent) in Mexico in 1967?
Make the answer very short. 33.01. What is the difference between the Emissions(in percent) of Barbados in 1966 and the Emissions(in percent) of Mozambique in 1967?
Provide a short and direct response. 61.84. What is the difference between the Emissions(in percent) in Barbados in 1966 and the Emissions(in percent) in Qatar in 1967?
Your answer should be compact. 92.66. What is the difference between the Emissions(in percent) of Mexico in 1966 and the Emissions(in percent) of Mozambique in 1967?
Ensure brevity in your answer.  28.16. What is the difference between the Emissions(in percent) in Mexico in 1966 and the Emissions(in percent) in Qatar in 1967?
Your response must be concise. 58.97. What is the difference between the Emissions(in percent) of Mozambique in 1966 and the Emissions(in percent) of Qatar in 1967?
Offer a very short reply. 36.77. What is the average Emissions(in percent) in Barbados per year?
Your answer should be compact. 96.68. What is the average Emissions(in percent) in Mexico per year?
Your response must be concise. 64.8. What is the average Emissions(in percent) in Mozambique per year?
Ensure brevity in your answer.  29.04. What is the average Emissions(in percent) of Qatar per year?
Give a very brief answer. 39.25. In the year 1960, what is the difference between the Emissions(in percent) in Barbados and Emissions(in percent) in Mexico?
Your response must be concise. 27.61. In the year 1960, what is the difference between the Emissions(in percent) of Barbados and Emissions(in percent) of Mozambique?
Keep it short and to the point. 72.59. In the year 1960, what is the difference between the Emissions(in percent) in Barbados and Emissions(in percent) in Qatar?
Provide a succinct answer. -4.26. In the year 1960, what is the difference between the Emissions(in percent) of Mexico and Emissions(in percent) of Mozambique?
Provide a succinct answer. 44.98. In the year 1960, what is the difference between the Emissions(in percent) of Mexico and Emissions(in percent) of Qatar?
Make the answer very short. -31.87. In the year 1960, what is the difference between the Emissions(in percent) in Mozambique and Emissions(in percent) in Qatar?
Your answer should be compact. -76.85. In the year 1961, what is the difference between the Emissions(in percent) of Barbados and Emissions(in percent) of Mexico?
Offer a very short reply. 27.31. In the year 1961, what is the difference between the Emissions(in percent) in Barbados and Emissions(in percent) in Mozambique?
Make the answer very short. 57.23. In the year 1961, what is the difference between the Emissions(in percent) in Barbados and Emissions(in percent) in Qatar?
Provide a short and direct response. -3.77. In the year 1961, what is the difference between the Emissions(in percent) in Mexico and Emissions(in percent) in Mozambique?
Give a very brief answer. 29.92. In the year 1961, what is the difference between the Emissions(in percent) in Mexico and Emissions(in percent) in Qatar?
Offer a terse response. -31.08. In the year 1961, what is the difference between the Emissions(in percent) in Mozambique and Emissions(in percent) in Qatar?
Your response must be concise. -61. In the year 1962, what is the difference between the Emissions(in percent) in Barbados and Emissions(in percent) in Mexico?
Make the answer very short. 30.95. In the year 1962, what is the difference between the Emissions(in percent) in Barbados and Emissions(in percent) in Mozambique?
Your answer should be very brief. 78.36. In the year 1962, what is the difference between the Emissions(in percent) in Barbados and Emissions(in percent) in Qatar?
Offer a very short reply. -2.82. In the year 1962, what is the difference between the Emissions(in percent) of Mexico and Emissions(in percent) of Mozambique?
Provide a succinct answer. 47.41. In the year 1962, what is the difference between the Emissions(in percent) of Mexico and Emissions(in percent) of Qatar?
Your answer should be very brief. -33.77. In the year 1962, what is the difference between the Emissions(in percent) in Mozambique and Emissions(in percent) in Qatar?
Keep it short and to the point. -81.18. In the year 1963, what is the difference between the Emissions(in percent) in Barbados and Emissions(in percent) in Mexico?
Your answer should be very brief. 31.64. In the year 1963, what is the difference between the Emissions(in percent) in Barbados and Emissions(in percent) in Mozambique?
Make the answer very short. 83.13. In the year 1963, what is the difference between the Emissions(in percent) in Barbados and Emissions(in percent) in Qatar?
Offer a terse response. 92.99. In the year 1963, what is the difference between the Emissions(in percent) of Mexico and Emissions(in percent) of Mozambique?
Provide a succinct answer. 51.49. In the year 1963, what is the difference between the Emissions(in percent) of Mexico and Emissions(in percent) of Qatar?
Make the answer very short. 61.35. In the year 1963, what is the difference between the Emissions(in percent) in Mozambique and Emissions(in percent) in Qatar?
Keep it short and to the point. 9.86. In the year 1964, what is the difference between the Emissions(in percent) of Barbados and Emissions(in percent) of Mexico?
Your answer should be compact. 35.37. In the year 1964, what is the difference between the Emissions(in percent) of Barbados and Emissions(in percent) of Mozambique?
Keep it short and to the point. 64.91. In the year 1964, what is the difference between the Emissions(in percent) of Barbados and Emissions(in percent) of Qatar?
Make the answer very short. 95.5. In the year 1964, what is the difference between the Emissions(in percent) of Mexico and Emissions(in percent) of Mozambique?
Your answer should be compact. 29.54. In the year 1964, what is the difference between the Emissions(in percent) of Mexico and Emissions(in percent) of Qatar?
Make the answer very short. 60.13. In the year 1964, what is the difference between the Emissions(in percent) in Mozambique and Emissions(in percent) in Qatar?
Make the answer very short. 30.59. In the year 1965, what is the difference between the Emissions(in percent) of Barbados and Emissions(in percent) of Mexico?
Offer a very short reply. 33.52. In the year 1965, what is the difference between the Emissions(in percent) in Barbados and Emissions(in percent) in Mozambique?
Your answer should be compact. 65.17. In the year 1965, what is the difference between the Emissions(in percent) in Barbados and Emissions(in percent) in Qatar?
Your response must be concise. 93.75. In the year 1965, what is the difference between the Emissions(in percent) of Mexico and Emissions(in percent) of Mozambique?
Offer a very short reply. 31.65. In the year 1965, what is the difference between the Emissions(in percent) in Mexico and Emissions(in percent) in Qatar?
Make the answer very short. 60.23. In the year 1965, what is the difference between the Emissions(in percent) of Mozambique and Emissions(in percent) of Qatar?
Provide a succinct answer. 28.58. In the year 1966, what is the difference between the Emissions(in percent) of Barbados and Emissions(in percent) of Mexico?
Keep it short and to the point. 33.68. In the year 1966, what is the difference between the Emissions(in percent) of Barbados and Emissions(in percent) of Mozambique?
Your answer should be compact. 55.89. In the year 1966, what is the difference between the Emissions(in percent) of Barbados and Emissions(in percent) of Qatar?
Provide a succinct answer. 93.44. In the year 1966, what is the difference between the Emissions(in percent) of Mexico and Emissions(in percent) of Mozambique?
Offer a terse response. 22.21. In the year 1966, what is the difference between the Emissions(in percent) of Mexico and Emissions(in percent) of Qatar?
Offer a very short reply. 59.75. In the year 1966, what is the difference between the Emissions(in percent) in Mozambique and Emissions(in percent) in Qatar?
Keep it short and to the point. 37.55. In the year 1967, what is the difference between the Emissions(in percent) in Barbados and Emissions(in percent) in Mexico?
Your answer should be compact. 34.95. In the year 1967, what is the difference between the Emissions(in percent) of Barbados and Emissions(in percent) of Mozambique?
Your answer should be very brief. 63.78. In the year 1967, what is the difference between the Emissions(in percent) of Barbados and Emissions(in percent) of Qatar?
Offer a terse response. 94.59. In the year 1967, what is the difference between the Emissions(in percent) of Mexico and Emissions(in percent) of Mozambique?
Your answer should be very brief. 28.83. In the year 1967, what is the difference between the Emissions(in percent) in Mexico and Emissions(in percent) in Qatar?
Your answer should be compact. 59.64. In the year 1967, what is the difference between the Emissions(in percent) of Mozambique and Emissions(in percent) of Qatar?
Ensure brevity in your answer.  30.82. What is the ratio of the Emissions(in percent) in Mozambique in 1960 to that in 1961?
Make the answer very short. 0.59. What is the ratio of the Emissions(in percent) of Qatar in 1960 to that in 1961?
Offer a very short reply. 1. What is the ratio of the Emissions(in percent) of Barbados in 1960 to that in 1962?
Provide a short and direct response. 0.99. What is the ratio of the Emissions(in percent) of Mexico in 1960 to that in 1962?
Your answer should be very brief. 1.03. What is the ratio of the Emissions(in percent) of Mozambique in 1960 to that in 1962?
Your answer should be compact. 1.23. What is the ratio of the Emissions(in percent) of Qatar in 1960 to that in 1962?
Offer a terse response. 1. What is the ratio of the Emissions(in percent) of Barbados in 1960 to that in 1963?
Provide a succinct answer. 1. What is the ratio of the Emissions(in percent) of Mexico in 1960 to that in 1963?
Make the answer very short. 1.06. What is the ratio of the Emissions(in percent) in Mozambique in 1960 to that in 1963?
Your answer should be compact. 1.78. What is the ratio of the Emissions(in percent) of Qatar in 1960 to that in 1963?
Provide a short and direct response. 31.58. What is the ratio of the Emissions(in percent) of Barbados in 1960 to that in 1964?
Provide a succinct answer. 0.98. What is the ratio of the Emissions(in percent) of Mexico in 1960 to that in 1964?
Make the answer very short. 1.09. What is the ratio of the Emissions(in percent) of Mozambique in 1960 to that in 1964?
Offer a terse response. 0.7. What is the ratio of the Emissions(in percent) in Qatar in 1960 to that in 1964?
Give a very brief answer. 40.74. What is the ratio of the Emissions(in percent) in Mexico in 1960 to that in 1965?
Keep it short and to the point. 1.08. What is the ratio of the Emissions(in percent) in Mozambique in 1960 to that in 1965?
Provide a short and direct response. 0.74. What is the ratio of the Emissions(in percent) in Qatar in 1960 to that in 1965?
Keep it short and to the point. 37.3. What is the ratio of the Emissions(in percent) in Mexico in 1960 to that in 1966?
Provide a short and direct response. 1.1. What is the ratio of the Emissions(in percent) in Mozambique in 1960 to that in 1966?
Ensure brevity in your answer.  0.58. What is the ratio of the Emissions(in percent) of Qatar in 1960 to that in 1966?
Offer a terse response. 40.76. What is the ratio of the Emissions(in percent) of Barbados in 1960 to that in 1967?
Ensure brevity in your answer.  0.98. What is the ratio of the Emissions(in percent) in Mexico in 1960 to that in 1967?
Provide a short and direct response. 1.08. What is the ratio of the Emissions(in percent) in Mozambique in 1960 to that in 1967?
Offer a terse response. 0.68. What is the ratio of the Emissions(in percent) of Qatar in 1960 to that in 1967?
Your answer should be very brief. 30.92. What is the ratio of the Emissions(in percent) in Barbados in 1961 to that in 1962?
Your response must be concise. 0.99. What is the ratio of the Emissions(in percent) in Mexico in 1961 to that in 1962?
Provide a succinct answer. 1.04. What is the ratio of the Emissions(in percent) in Mozambique in 1961 to that in 1962?
Make the answer very short. 2.07. What is the ratio of the Emissions(in percent) in Barbados in 1961 to that in 1963?
Your answer should be compact. 1. What is the ratio of the Emissions(in percent) of Mexico in 1961 to that in 1963?
Your answer should be compact. 1.07. What is the ratio of the Emissions(in percent) of Mozambique in 1961 to that in 1963?
Make the answer very short. 2.99. What is the ratio of the Emissions(in percent) of Qatar in 1961 to that in 1963?
Keep it short and to the point. 31.58. What is the ratio of the Emissions(in percent) in Barbados in 1961 to that in 1964?
Provide a short and direct response. 0.98. What is the ratio of the Emissions(in percent) in Mexico in 1961 to that in 1964?
Provide a short and direct response. 1.1. What is the ratio of the Emissions(in percent) in Mozambique in 1961 to that in 1964?
Your response must be concise. 1.18. What is the ratio of the Emissions(in percent) of Qatar in 1961 to that in 1964?
Your answer should be very brief. 40.74. What is the ratio of the Emissions(in percent) in Barbados in 1961 to that in 1965?
Your response must be concise. 1. What is the ratio of the Emissions(in percent) of Mexico in 1961 to that in 1965?
Ensure brevity in your answer.  1.1. What is the ratio of the Emissions(in percent) of Mozambique in 1961 to that in 1965?
Make the answer very short. 1.25. What is the ratio of the Emissions(in percent) of Qatar in 1961 to that in 1965?
Ensure brevity in your answer.  37.3. What is the ratio of the Emissions(in percent) in Mexico in 1961 to that in 1966?
Give a very brief answer. 1.11. What is the ratio of the Emissions(in percent) of Mozambique in 1961 to that in 1966?
Provide a succinct answer. 0.97. What is the ratio of the Emissions(in percent) in Qatar in 1961 to that in 1966?
Your answer should be very brief. 40.76. What is the ratio of the Emissions(in percent) in Barbados in 1961 to that in 1967?
Ensure brevity in your answer.  0.98. What is the ratio of the Emissions(in percent) of Mexico in 1961 to that in 1967?
Ensure brevity in your answer.  1.1. What is the ratio of the Emissions(in percent) in Mozambique in 1961 to that in 1967?
Keep it short and to the point. 1.15. What is the ratio of the Emissions(in percent) in Qatar in 1961 to that in 1967?
Offer a terse response. 30.92. What is the ratio of the Emissions(in percent) in Barbados in 1962 to that in 1963?
Your answer should be compact. 1.01. What is the ratio of the Emissions(in percent) of Mexico in 1962 to that in 1963?
Offer a very short reply. 1.03. What is the ratio of the Emissions(in percent) in Mozambique in 1962 to that in 1963?
Offer a very short reply. 1.44. What is the ratio of the Emissions(in percent) in Qatar in 1962 to that in 1963?
Provide a short and direct response. 31.58. What is the ratio of the Emissions(in percent) of Barbados in 1962 to that in 1964?
Your answer should be very brief. 0.99. What is the ratio of the Emissions(in percent) in Mexico in 1962 to that in 1964?
Ensure brevity in your answer.  1.06. What is the ratio of the Emissions(in percent) of Mozambique in 1962 to that in 1964?
Your answer should be very brief. 0.57. What is the ratio of the Emissions(in percent) of Qatar in 1962 to that in 1964?
Your response must be concise. 40.74. What is the ratio of the Emissions(in percent) in Barbados in 1962 to that in 1965?
Offer a terse response. 1.01. What is the ratio of the Emissions(in percent) of Mexico in 1962 to that in 1965?
Offer a very short reply. 1.05. What is the ratio of the Emissions(in percent) in Mozambique in 1962 to that in 1965?
Offer a terse response. 0.6. What is the ratio of the Emissions(in percent) in Qatar in 1962 to that in 1965?
Make the answer very short. 37.3. What is the ratio of the Emissions(in percent) of Barbados in 1962 to that in 1966?
Give a very brief answer. 1.01. What is the ratio of the Emissions(in percent) in Mexico in 1962 to that in 1966?
Make the answer very short. 1.06. What is the ratio of the Emissions(in percent) in Mozambique in 1962 to that in 1966?
Provide a succinct answer. 0.47. What is the ratio of the Emissions(in percent) of Qatar in 1962 to that in 1966?
Offer a terse response. 40.76. What is the ratio of the Emissions(in percent) of Barbados in 1962 to that in 1967?
Ensure brevity in your answer.  0.99. What is the ratio of the Emissions(in percent) of Mexico in 1962 to that in 1967?
Ensure brevity in your answer.  1.05. What is the ratio of the Emissions(in percent) in Mozambique in 1962 to that in 1967?
Give a very brief answer. 0.55. What is the ratio of the Emissions(in percent) of Qatar in 1962 to that in 1967?
Your answer should be compact. 30.92. What is the ratio of the Emissions(in percent) in Barbados in 1963 to that in 1964?
Offer a terse response. 0.98. What is the ratio of the Emissions(in percent) in Mexico in 1963 to that in 1964?
Provide a short and direct response. 1.03. What is the ratio of the Emissions(in percent) of Mozambique in 1963 to that in 1964?
Your answer should be compact. 0.39. What is the ratio of the Emissions(in percent) in Qatar in 1963 to that in 1964?
Keep it short and to the point. 1.29. What is the ratio of the Emissions(in percent) in Mexico in 1963 to that in 1965?
Your answer should be compact. 1.03. What is the ratio of the Emissions(in percent) of Mozambique in 1963 to that in 1965?
Offer a very short reply. 0.42. What is the ratio of the Emissions(in percent) in Qatar in 1963 to that in 1965?
Your answer should be compact. 1.18. What is the ratio of the Emissions(in percent) of Mexico in 1963 to that in 1966?
Make the answer very short. 1.04. What is the ratio of the Emissions(in percent) in Mozambique in 1963 to that in 1966?
Make the answer very short. 0.33. What is the ratio of the Emissions(in percent) of Qatar in 1963 to that in 1966?
Provide a short and direct response. 1.29. What is the ratio of the Emissions(in percent) in Barbados in 1963 to that in 1967?
Make the answer very short. 0.98. What is the ratio of the Emissions(in percent) of Mexico in 1963 to that in 1967?
Provide a succinct answer. 1.03. What is the ratio of the Emissions(in percent) in Mozambique in 1963 to that in 1967?
Offer a very short reply. 0.38. What is the ratio of the Emissions(in percent) in Qatar in 1963 to that in 1967?
Keep it short and to the point. 0.98. What is the ratio of the Emissions(in percent) of Barbados in 1964 to that in 1965?
Offer a very short reply. 1.02. What is the ratio of the Emissions(in percent) of Mexico in 1964 to that in 1965?
Ensure brevity in your answer.  0.99. What is the ratio of the Emissions(in percent) of Mozambique in 1964 to that in 1965?
Your response must be concise. 1.06. What is the ratio of the Emissions(in percent) in Qatar in 1964 to that in 1965?
Provide a short and direct response. 0.92. What is the ratio of the Emissions(in percent) of Barbados in 1964 to that in 1966?
Offer a terse response. 1.02. What is the ratio of the Emissions(in percent) of Mozambique in 1964 to that in 1966?
Offer a terse response. 0.83. What is the ratio of the Emissions(in percent) in Qatar in 1964 to that in 1966?
Make the answer very short. 1. What is the ratio of the Emissions(in percent) of Mexico in 1964 to that in 1967?
Provide a succinct answer. 1. What is the ratio of the Emissions(in percent) in Mozambique in 1964 to that in 1967?
Provide a short and direct response. 0.97. What is the ratio of the Emissions(in percent) in Qatar in 1964 to that in 1967?
Ensure brevity in your answer.  0.76. What is the ratio of the Emissions(in percent) in Barbados in 1965 to that in 1966?
Keep it short and to the point. 1.01. What is the ratio of the Emissions(in percent) of Mexico in 1965 to that in 1966?
Give a very brief answer. 1.01. What is the ratio of the Emissions(in percent) in Mozambique in 1965 to that in 1966?
Provide a short and direct response. 0.78. What is the ratio of the Emissions(in percent) in Qatar in 1965 to that in 1966?
Make the answer very short. 1.09. What is the ratio of the Emissions(in percent) of Barbados in 1965 to that in 1967?
Your response must be concise. 0.99. What is the ratio of the Emissions(in percent) of Mozambique in 1965 to that in 1967?
Offer a very short reply. 0.92. What is the ratio of the Emissions(in percent) of Qatar in 1965 to that in 1967?
Your answer should be very brief. 0.83. What is the ratio of the Emissions(in percent) of Barbados in 1966 to that in 1967?
Your answer should be compact. 0.98. What is the ratio of the Emissions(in percent) in Mexico in 1966 to that in 1967?
Your answer should be compact. 0.99. What is the ratio of the Emissions(in percent) in Mozambique in 1966 to that in 1967?
Offer a very short reply. 1.17. What is the ratio of the Emissions(in percent) in Qatar in 1966 to that in 1967?
Keep it short and to the point. 0.76. What is the difference between the highest and the second highest Emissions(in percent) in Barbados?
Your answer should be very brief. 0.13. What is the difference between the highest and the second highest Emissions(in percent) of Mexico?
Your response must be concise. 0.79. What is the difference between the highest and the lowest Emissions(in percent) of Barbados?
Keep it short and to the point. 2.21. What is the difference between the highest and the lowest Emissions(in percent) of Mexico?
Offer a terse response. 6.71. What is the difference between the highest and the lowest Emissions(in percent) in Mozambique?
Provide a succinct answer. 26.98. What is the difference between the highest and the lowest Emissions(in percent) in Qatar?
Provide a succinct answer. 97.55. 